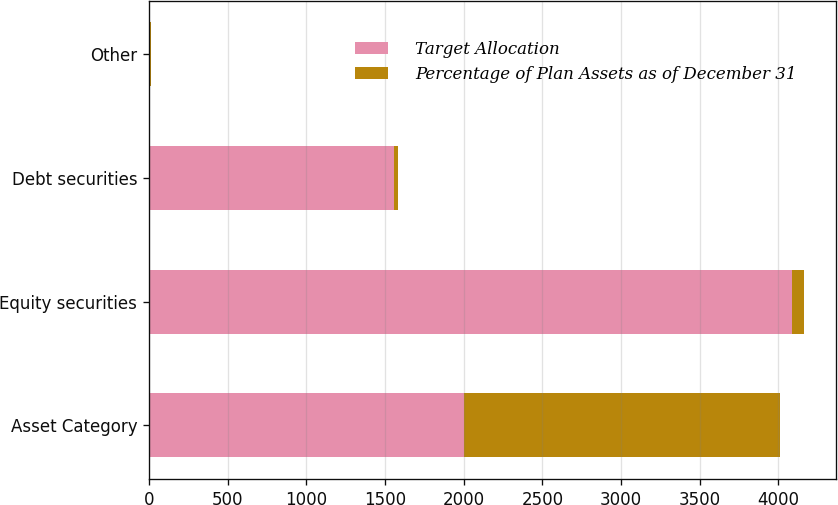<chart> <loc_0><loc_0><loc_500><loc_500><stacked_bar_chart><ecel><fcel>Asset Category<fcel>Equity securities<fcel>Debt securities<fcel>Other<nl><fcel>Target Allocation<fcel>2005<fcel>4085<fcel>1560<fcel>10<nl><fcel>Percentage of Plan Assets as of December 31<fcel>2004<fcel>75<fcel>24<fcel>1<nl></chart> 